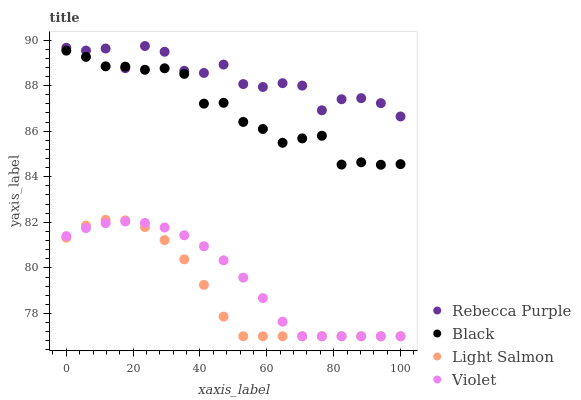Does Light Salmon have the minimum area under the curve?
Answer yes or no. Yes. Does Rebecca Purple have the maximum area under the curve?
Answer yes or no. Yes. Does Black have the minimum area under the curve?
Answer yes or no. No. Does Black have the maximum area under the curve?
Answer yes or no. No. Is Violet the smoothest?
Answer yes or no. Yes. Is Rebecca Purple the roughest?
Answer yes or no. Yes. Is Black the smoothest?
Answer yes or no. No. Is Black the roughest?
Answer yes or no. No. Does Light Salmon have the lowest value?
Answer yes or no. Yes. Does Black have the lowest value?
Answer yes or no. No. Does Rebecca Purple have the highest value?
Answer yes or no. Yes. Does Black have the highest value?
Answer yes or no. No. Is Light Salmon less than Black?
Answer yes or no. Yes. Is Black greater than Violet?
Answer yes or no. Yes. Does Black intersect Rebecca Purple?
Answer yes or no. Yes. Is Black less than Rebecca Purple?
Answer yes or no. No. Is Black greater than Rebecca Purple?
Answer yes or no. No. Does Light Salmon intersect Black?
Answer yes or no. No. 